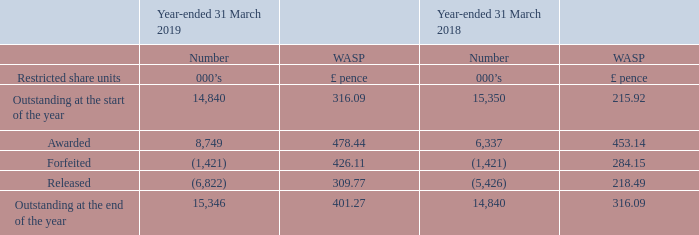Restricted Share Units
The following table illustrates the number and WASP on date of award, and movements in, restricted share units (“RSUs”) and cash-based awards granted under the 2015 LTIP:
RSUs and cash-based awards have a vesting period between two to five years, with no award vesting within the first 12 months of the grant.
What is the vesting period of RSUs and cash-based awards? Between two to five years, with no award vesting within the first 12 months of the grant. What was the number of RSUs and cash-based awards outstanding at the end of the year in 2019?
Answer scale should be: thousand. 15,346. What are the types of movements in restricted share units (“RSUs”) and cash-based awards in the table? Awarded, forfeited, released. In what year was the number of RSUs and cash-based awards outstanding at the end of the year larger? 15,346>14,840
Answer: 2019. What was the change in the number of RSUs and cash-based awards outstanding at the end of the year in 2019 from 2018?
Answer scale should be: thousand. 15,346-14,840
Answer: 506. What was the percentage change in the number of RSUs and cash-based awards outstanding at the end of the year in 2019 from 2018?
Answer scale should be: percent. (15,346-14,840)/14,840
Answer: 3.41. 